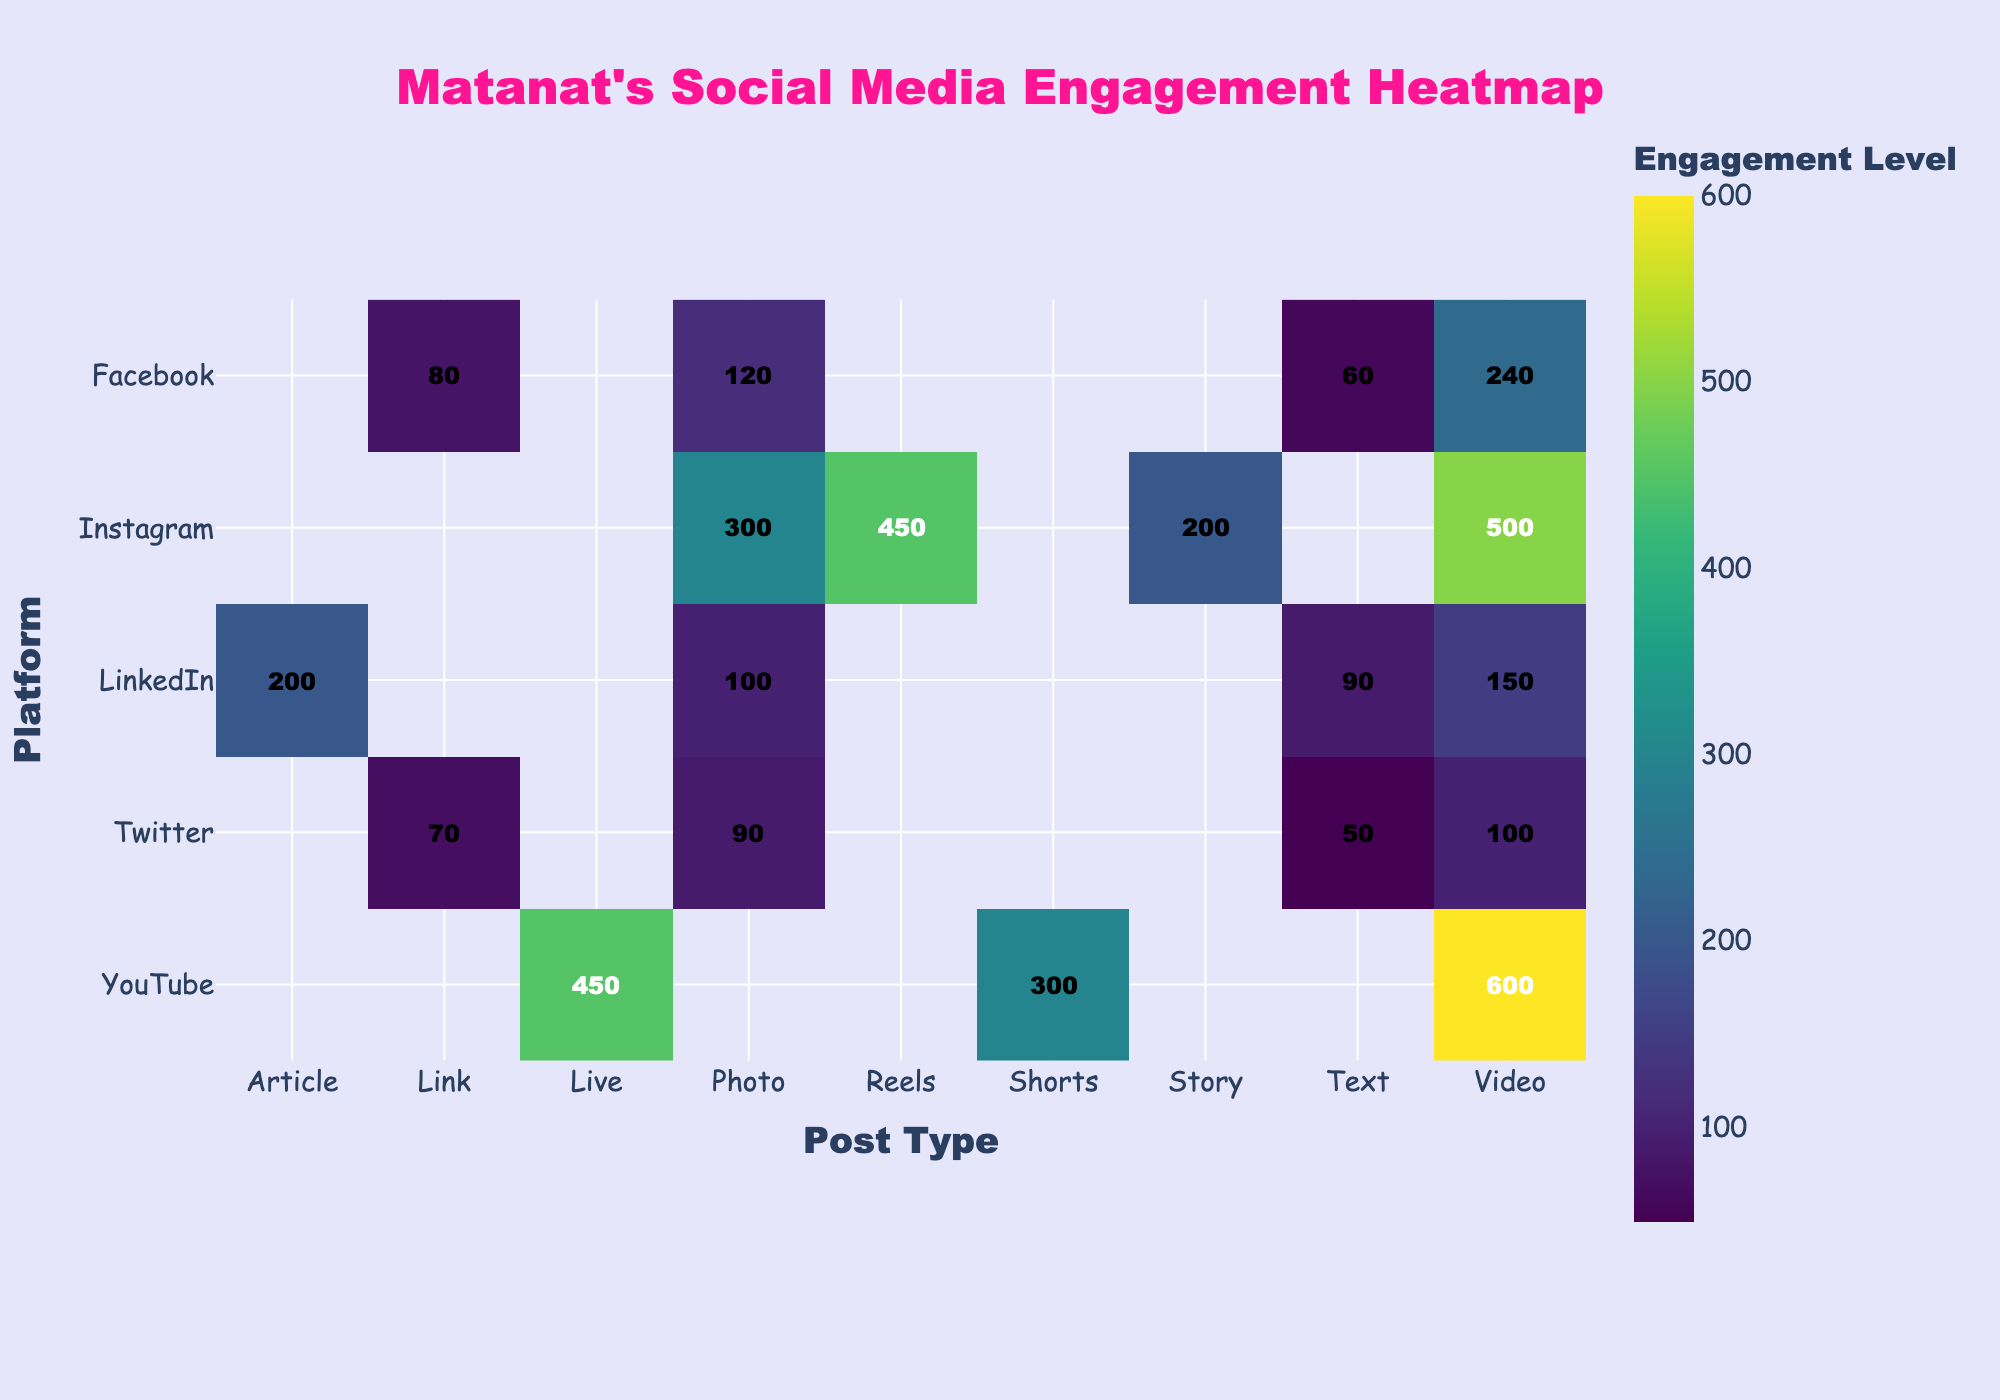What is the title of the heatmap? The title of the heatmap is often prominently displayed at the top of the figure. In this case, it's designed to be very noticeable with a distinctive color.
Answer: Matanat's Social Media Engagement Heatmap Which platform has the highest engagement for video posts? You need to locate the "Video" column and then find the cell with the highest value. You'll notice that the "YouTube" row has the highest value for video posts.
Answer: YouTube How does the engagement for Instagram Reels compare to Instagram Stories? Look at the cells intersecting the "Instagram" row with the "Reels" and "Story" columns. Reels has a higher value than Stories.
Answer: Reels has higher engagement What is the average engagement for all post types on Twitter? Extract the values for all post types under the "Twitter" row: 90, 100, 70, 50. Sum these values and then divide by the number of post types (which is 4).
Answer: 77.5 Which post type on Facebook has the lowest engagement? Find the row "Facebook" and then look for the lowest value among the post types. The "Text" post type will have the lowest engagement.
Answer: Text How many platforms have engagement greater than 400 for any post type? Look through each platform and count how many have at least one post type with engagement above 400. Instagram and YouTube qualify, adding up to 2 platforms.
Answer: 2 Compare photo engagement on LinkedIn vs Facebook. Which has higher engagement? Locate the "Photo" column and compare the values for "LinkedIn" and "Facebook" rows. LinkedIn's engagement is lower than Facebook's.
Answer: Facebook What is the engagement sum for LinkedIn article and text posts? Find the engagement values for Article and Text under the "LinkedIn" row: 200 and 90. Adding these two values gives 290.
Answer: 290 Which platform has the highest number of post types shown in the heatmap? Count the number of post types listed under each platform's row. The one with the most counts as the highest. Both Instagram and LinkedIn have the most post types shown (4 each).
Answer: Instagram and LinkedIn 